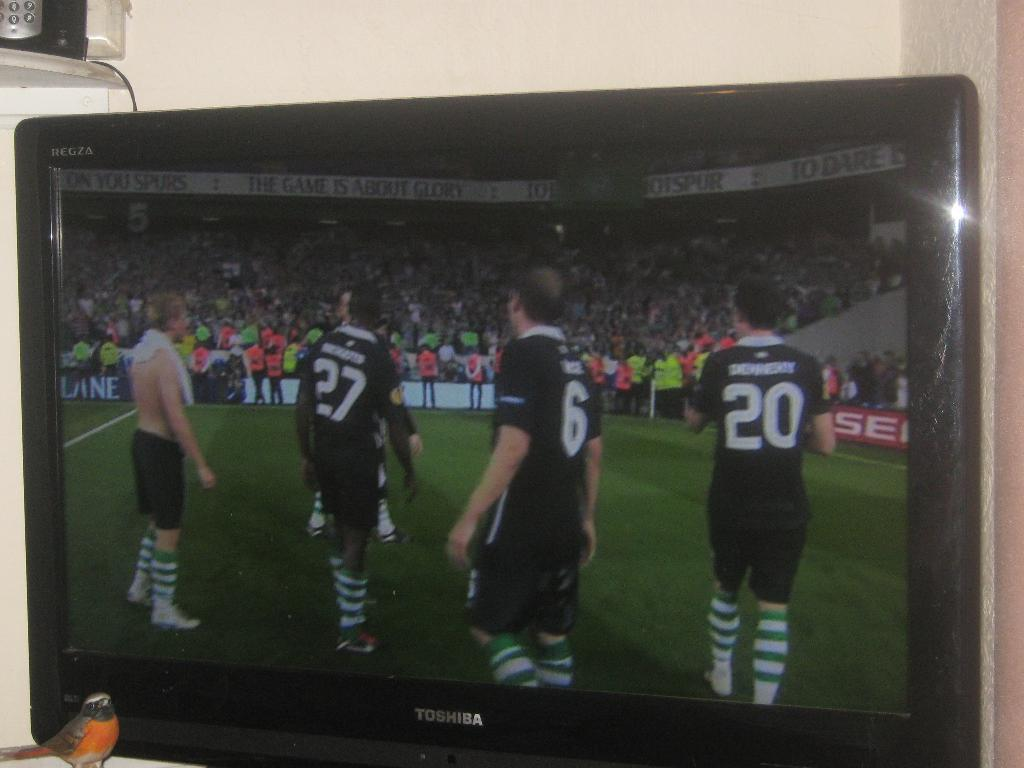Provide a one-sentence caption for the provided image. The screen of a toshiba branded television showing a soccer game with a bird standing near the television. 